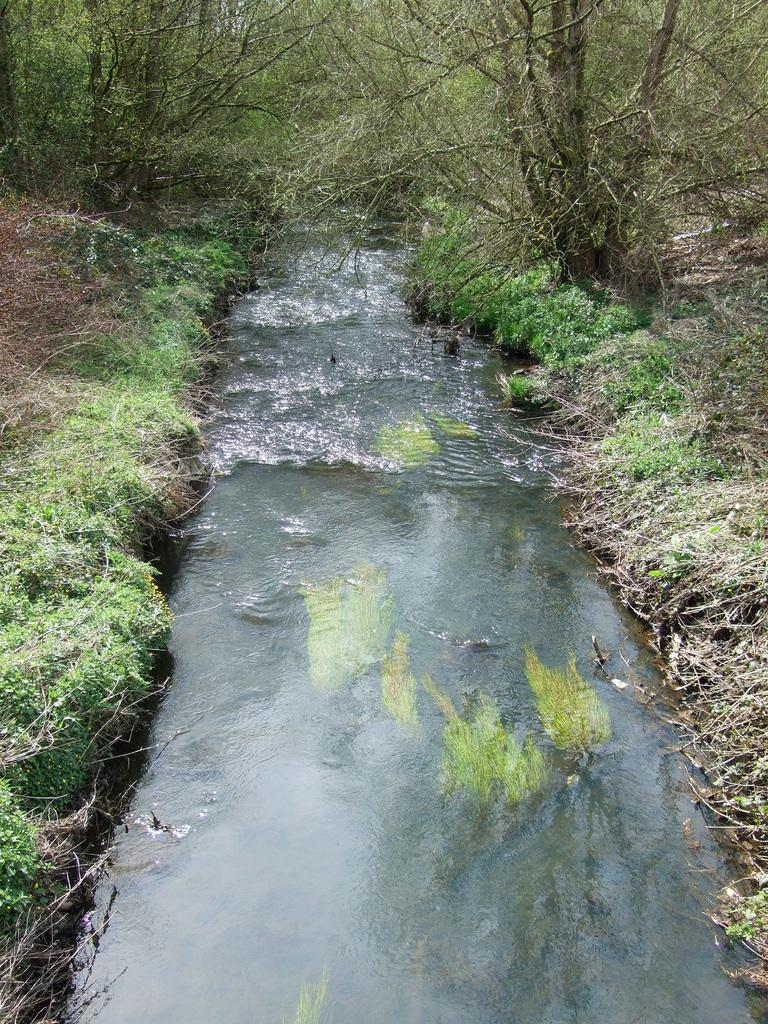What is the main feature in the middle of the image? There is a canal in the middle of the image. What can be seen on either side of the canal? Plants and grass are present on either side of the canal. How many pigs are swimming in the canal in the image? There are no pigs present in the image; it features a canal with plants and grass on either side. What type of coach can be seen driving along the canal in the image? There is no coach present in the image; it only features a canal, plants, and grass. 